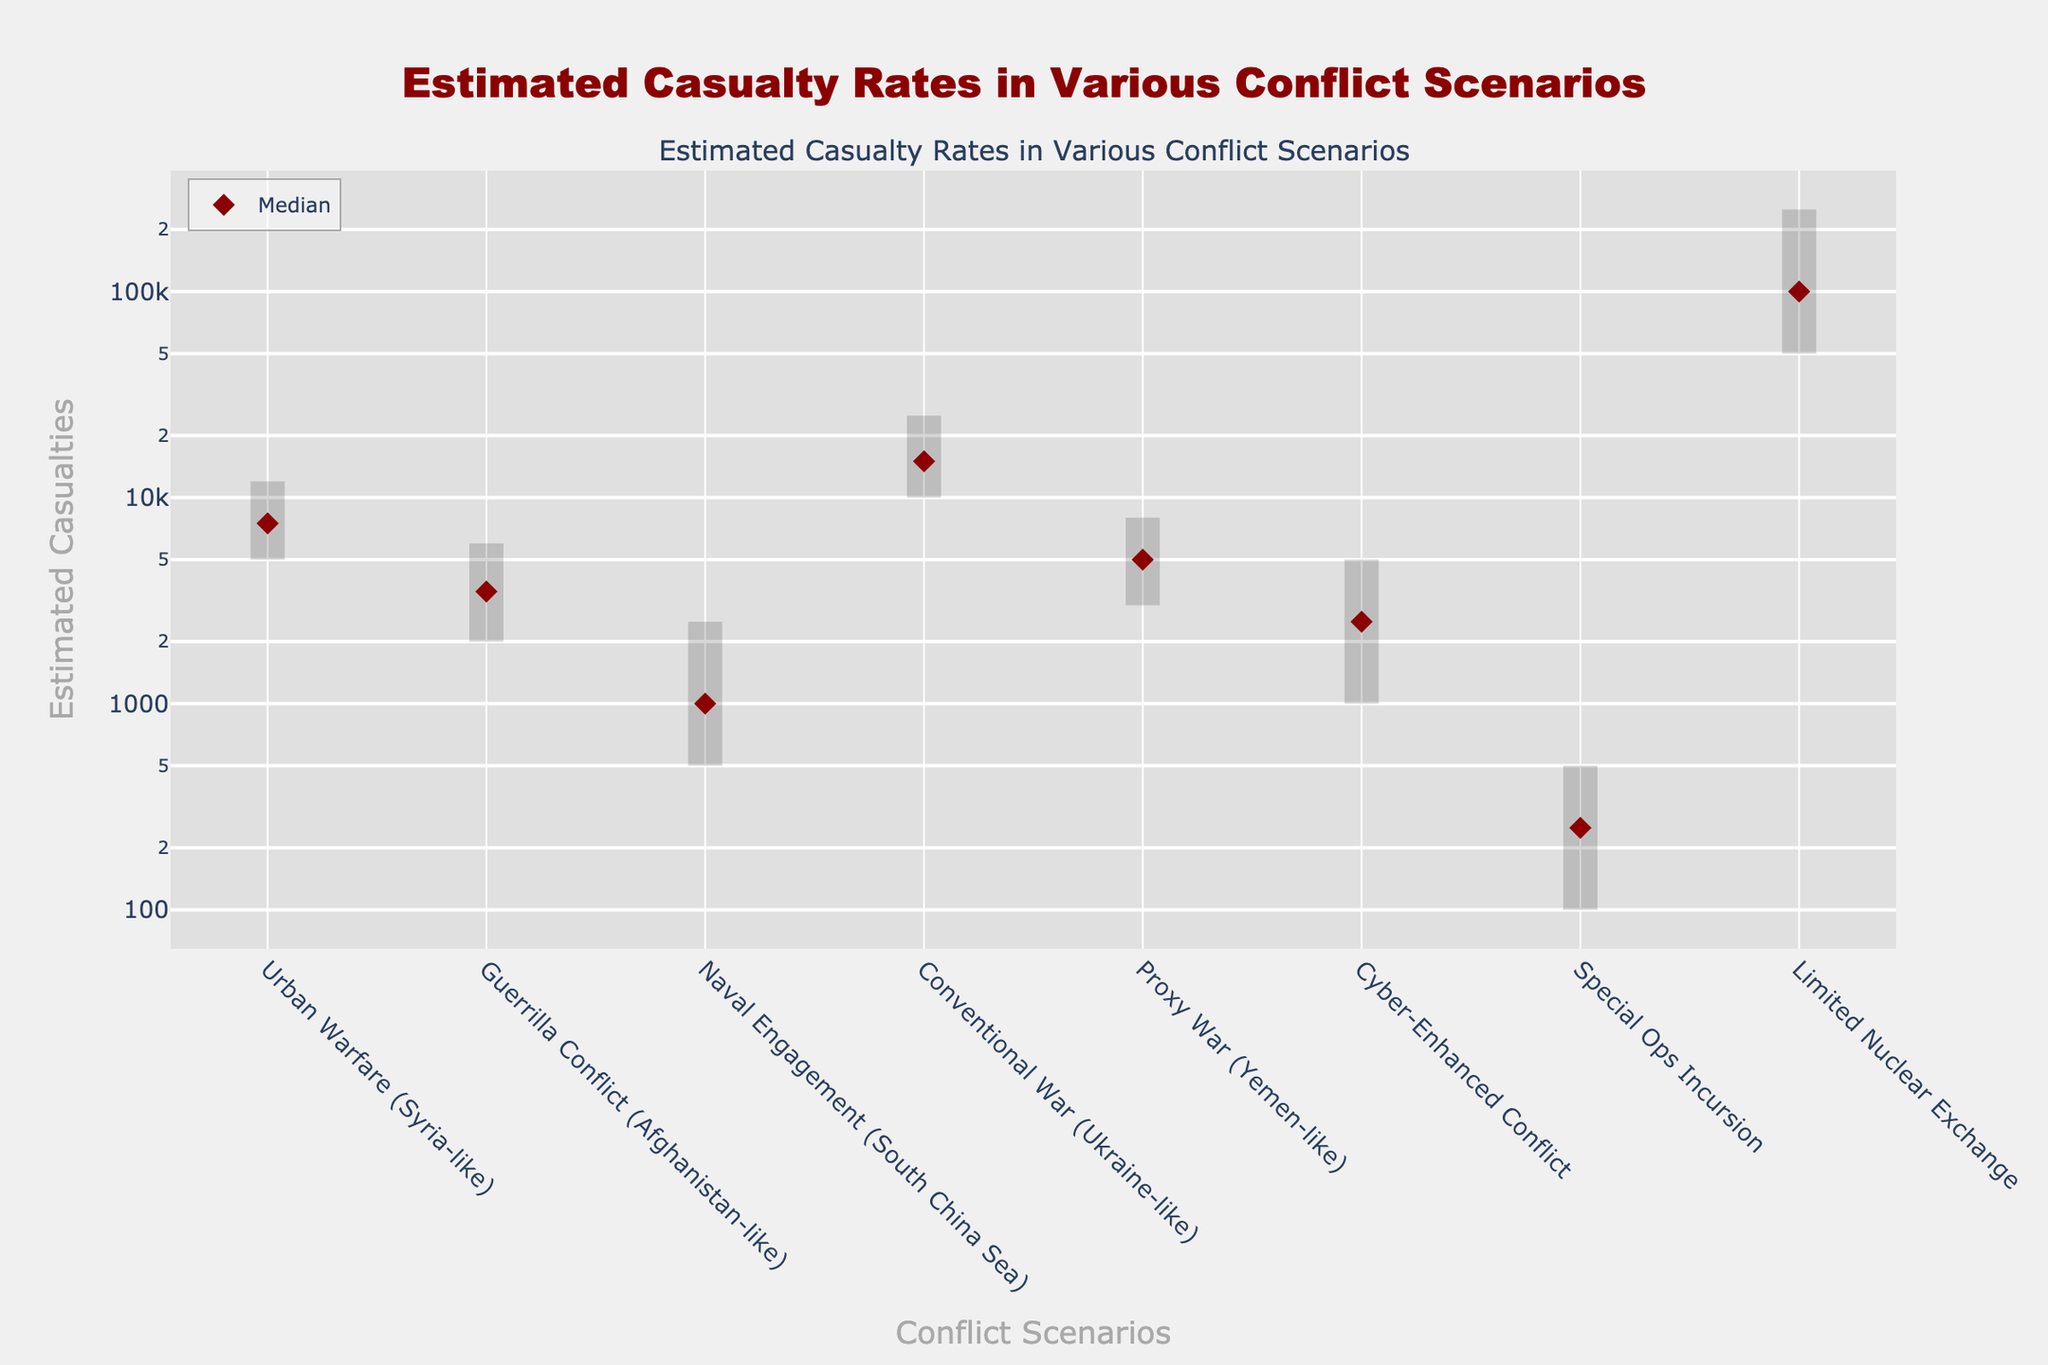what is the title of the figure? The title is located at the top center of the figure and is generally larger in font size compared to other text elements. It provides a concise summary of what the figure is about.
Answer: Estimated Casualty Rates in Various Conflict Scenarios Which scenario has the highest median estimated casualties? To determine this, locate the scenario with the tallest marker (the dark red diamond) along the vertical axis. The scenario with the highest marker represents the scenario with the highest median casualties.
Answer: Limited Nuclear Exchange What is the range of estimated casualties for the Naval Engagement scenario? Find the Naval Engagement scenario on the x-axis. Vertical lines will indicate the low and high estimates. The range is the difference between the high and low estimates.
Answer: 2000 How do the median estimated casualties in Urban Warfare compare to those in Guerrilla Conflict? Locate Urban Warfare and Guerrilla Conflict on the x-axis and check their median markers (dark red diamonds). Compare these markers to see which is higher.
Answer: Urban Warfare has higher median casualties What is the approximate median estimate for a Proxy War? Find the Proxy War scenario along the x-axis and look at the dark red diamond marker's vertical position. This indicates the median estimate.
Answer: 5000 Which scenario has the smallest range of estimated casualties? To find this, look for the scenario with the shortest vertical line, which represents the smallest difference between the high and low estimates.
Answer: Special Ops Incursion What do the colors of the lines and markers represent? The light-colored lines represent the range of estimated casualties from low to high. The dark red diamond markers represent the median estimate of casualties for each scenario.
Answer: Range and Median Which type of conflict shows an estimate range going into six figures? Locate the scenario with a vertical line that extends into the six-figure range on the y-axis. This would be the Limited Nuclear Exchange scenario.
Answer: Limited Nuclear Exchange How many scenarios estimate more than 10,000 casualties at the high end? Look for vertical lines that extend beyond the 10,000 mark on the y-axis. Count these scenarios to get the answer.
Answer: Three scenarios How does the estimated casualty range in Cyber-Enhanced Conflict compare to the Proxy War? Find both scenarios on the x-axis and compare their vertical lines. Note whether the upper and lower ends of these ranges are higher, lower, or equal.
Answer: Proxy War has a higher range 